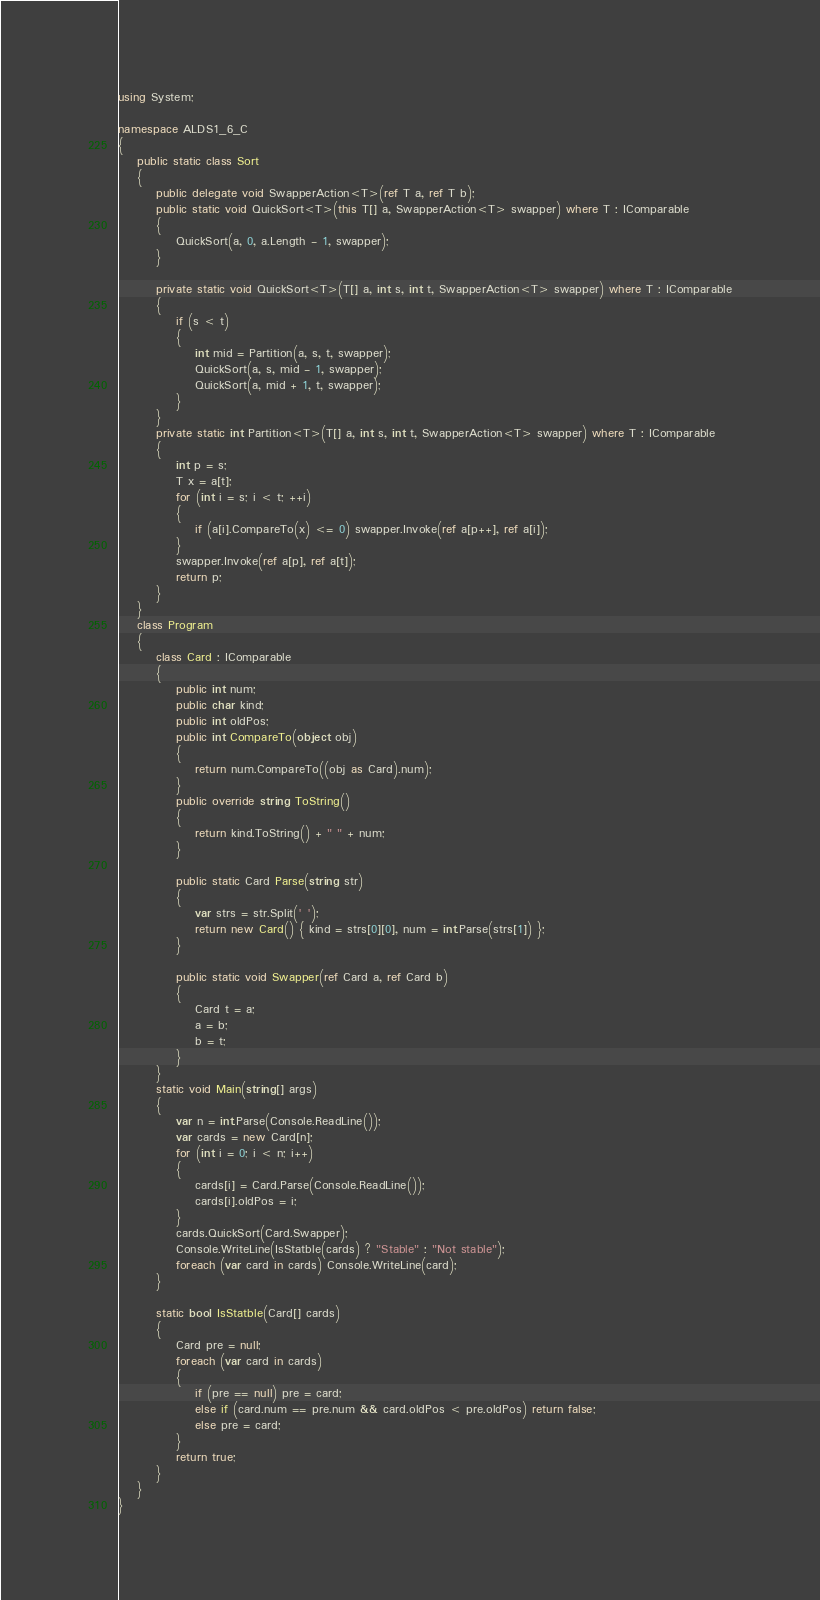Convert code to text. <code><loc_0><loc_0><loc_500><loc_500><_C#_>using System;

namespace ALDS1_6_C
{
    public static class Sort
    {
        public delegate void SwapperAction<T>(ref T a, ref T b);
        public static void QuickSort<T>(this T[] a, SwapperAction<T> swapper) where T : IComparable
        {
            QuickSort(a, 0, a.Length - 1, swapper);
        }

        private static void QuickSort<T>(T[] a, int s, int t, SwapperAction<T> swapper) where T : IComparable
        {
            if (s < t)
            {
                int mid = Partition(a, s, t, swapper);
                QuickSort(a, s, mid - 1, swapper);
                QuickSort(a, mid + 1, t, swapper);
            }
        }
        private static int Partition<T>(T[] a, int s, int t, SwapperAction<T> swapper) where T : IComparable
        {
            int p = s;
            T x = a[t];
            for (int i = s; i < t; ++i)
            {
                if (a[i].CompareTo(x) <= 0) swapper.Invoke(ref a[p++], ref a[i]);
            }
            swapper.Invoke(ref a[p], ref a[t]);
            return p;
        }
    }
    class Program
    {
        class Card : IComparable
        {
            public int num;
            public char kind;
            public int oldPos;
            public int CompareTo(object obj)
            {
                return num.CompareTo((obj as Card).num);
            }
            public override string ToString()
            {
                return kind.ToString() + " " + num; 
            }

            public static Card Parse(string str)
            {
                var strs = str.Split(' ');
                return new Card() { kind = strs[0][0], num = int.Parse(strs[1]) };
            }

            public static void Swapper(ref Card a, ref Card b)
            {
                Card t = a;
                a = b;
                b = t;
            }
        }
        static void Main(string[] args)
        {
            var n = int.Parse(Console.ReadLine());
            var cards = new Card[n];
            for (int i = 0; i < n; i++)
            {
                cards[i] = Card.Parse(Console.ReadLine());
                cards[i].oldPos = i;
            }
            cards.QuickSort(Card.Swapper);
            Console.WriteLine(IsStatble(cards) ? "Stable" : "Not stable");
            foreach (var card in cards) Console.WriteLine(card);
        }

        static bool IsStatble(Card[] cards)
        {
            Card pre = null;
            foreach (var card in cards)
            {
                if (pre == null) pre = card;
                else if (card.num == pre.num && card.oldPos < pre.oldPos) return false;
                else pre = card;
            }
            return true;
        }
    }
}</code> 